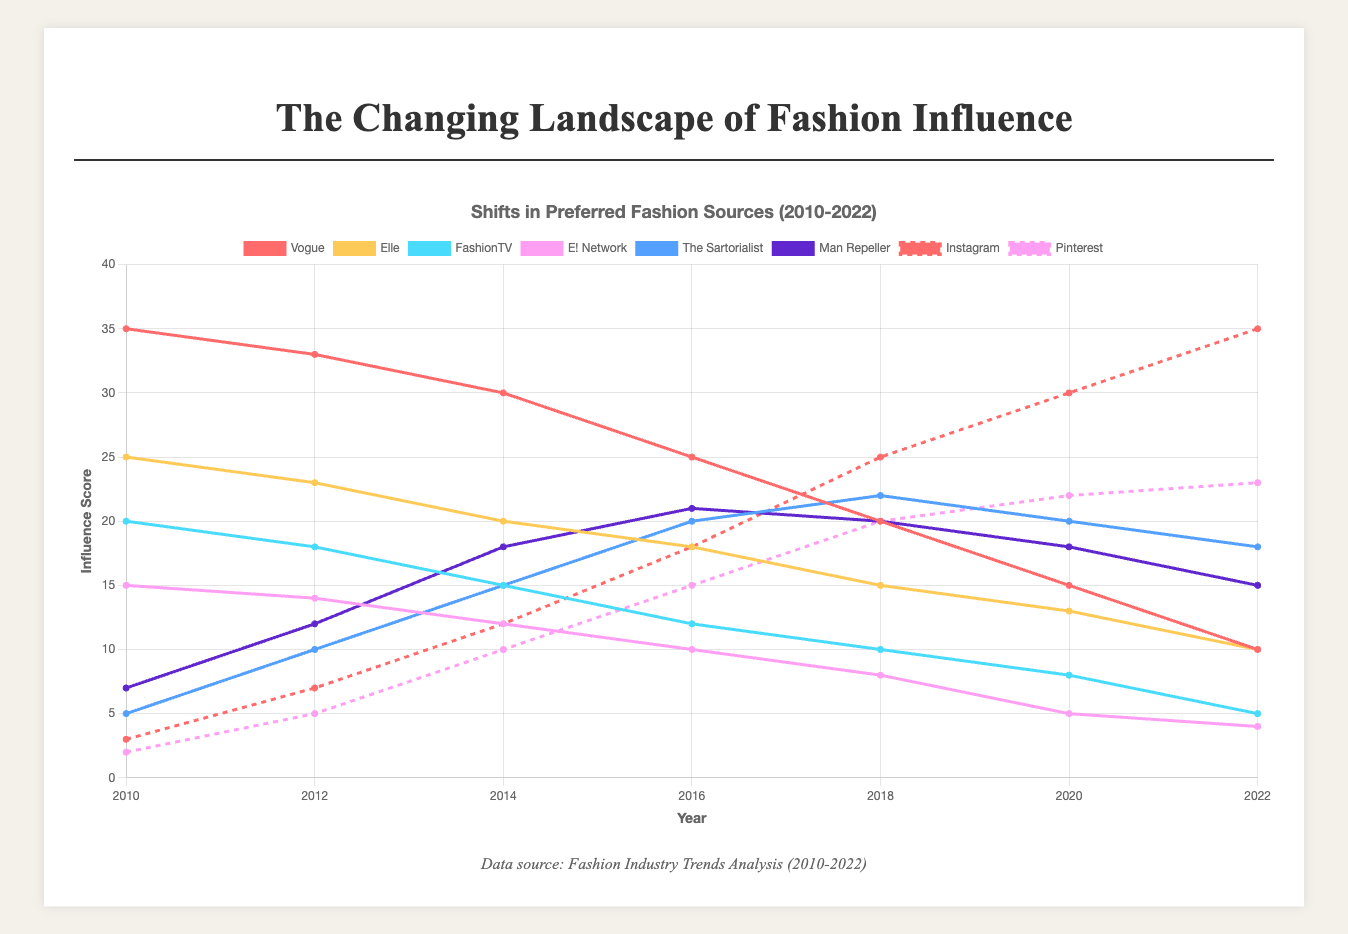What is the trend observed for Vogue from 2010 to 2022? The influence of Vogue shows a continuous decline from 35 in 2010 to 10 in 2022. This can be observed by noting the sequential decrease at each time point.
Answer: Decline Compare the influence scores of Instagram and Pinterest in 2022 and identify which one is higher. In 2022, Instagram has an influence score of 35, while Pinterest has 23. By comparing these values, we can see that Instagram has a higher score.
Answer: Instagram What is the combined influence score of The Sartorialist and Man Repeller in 2014? The influence score of The Sartorialist in 2014 is 15, and for Man Repeller, it's 18. Adding these together gives 15 + 18 = 33.
Answer: 33 Which data source showed the most significant increase in influence from 2010 to 2022? Comparing the change in influence scores from 2010 to 2022 for each source, Instagram shows the highest increase (from 3 to 35, a 32-point increase).
Answer: Instagram Compare Vogue's influence in 2012 and 2020. By how many points did it decline? Vogue's influence in 2012 is 33, and it drops to 15 in 2020. The difference is 33 - 15 = 18.
Answer: 18 Identify the data source with the smallest influence score in 2012. In 2012, the influence scores are: Vogue (33), Elle (23), FashionTV (18), E! Network (14), The Sartorialist (10), Man Repeller (12), Instagram (7), Pinterest (5). The smallest score is for Pinterest (5).
Answer: Pinterest What is the average influence score of FashionTV over the years 2010 to 2022? Summing the scores for FashionTV across the years gives 20 + 18 + 15 + 12 + 10 + 8 + 5 = 88. Dividing this sum by the number of years (7) gives an average of 88 / 7 ≈ 12.57.
Answer: 12.57 In 2016, which had a higher influence score: Elle or The Sartorialist? In 2016, Elle had an influence score of 18, and The Sartorialist had a score of 20. The Sartorialist's score is higher.
Answer: The Sartorialist Between 2018 and 2020, did Pinterest's influence increase or decrease, and by how much? Pinterest's influence was 20 in 2018 and rose to 22 in 2020. The increase is 22 - 20 = 2.
Answer: Increased by 2 Which data sources had declining trends throughout all measured years? Vogue, Elle, FashionTV, and E! Network show continuous declines in their influence scores throughout all measured years (2010-2022).
Answer: Vogue, Elle, FashionTV, E! Network 